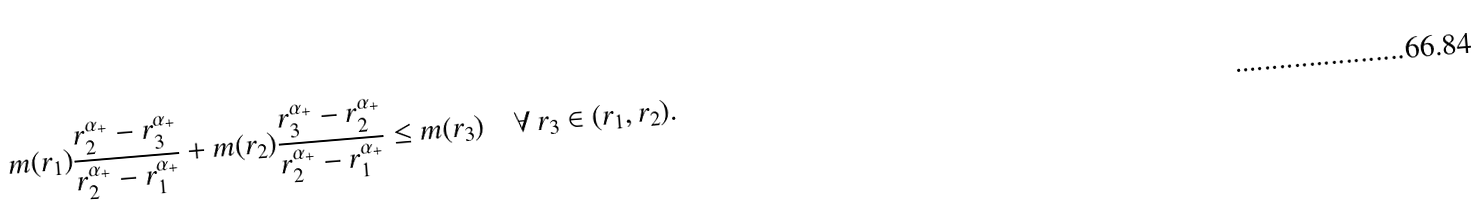<formula> <loc_0><loc_0><loc_500><loc_500>m ( r _ { 1 } ) \frac { r _ { 2 } ^ { \alpha _ { + } } - r _ { 3 } ^ { \alpha _ { + } } } { r _ { 2 } ^ { \alpha _ { + } } - r _ { 1 } ^ { \alpha _ { + } } } + m ( r _ { 2 } ) \frac { r _ { 3 } ^ { \alpha _ { + } } - r _ { 2 } ^ { \alpha _ { + } } } { r _ { 2 } ^ { \alpha _ { + } } - r _ { 1 } ^ { \alpha _ { + } } } \leq m ( r _ { 3 } ) \quad \forall \, r _ { 3 } \in ( r _ { 1 } , r _ { 2 } ) .</formula> 